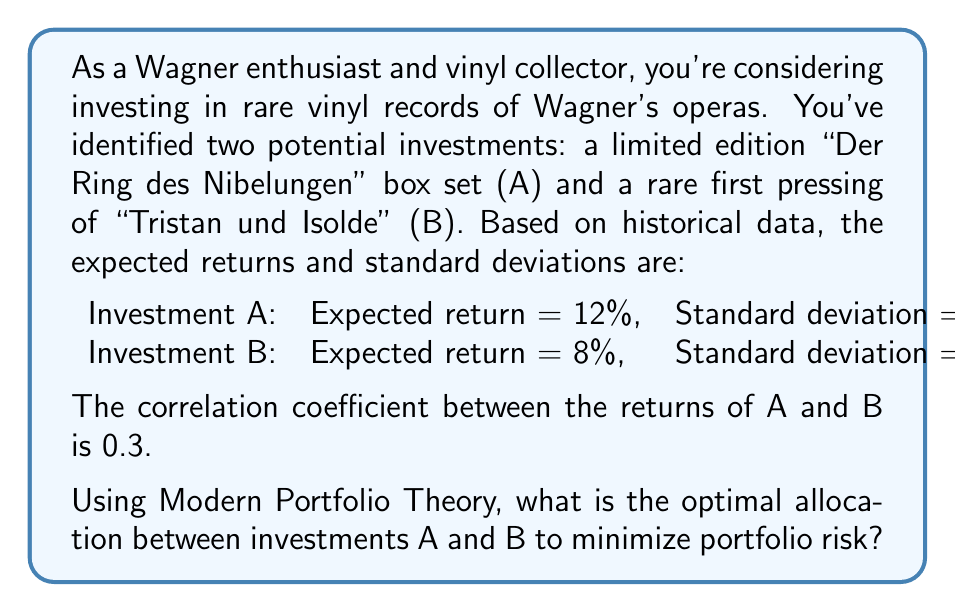Can you solve this math problem? To solve this problem, we'll use the principles of Modern Portfolio Theory to find the optimal allocation that minimizes portfolio risk. We'll follow these steps:

1. Calculate the portfolio variance formula
2. Find the derivative of the variance with respect to the weight of investment A
3. Set the derivative to zero and solve for the weight of A

Step 1: Portfolio variance formula

The portfolio variance is given by:

$$\sigma_p^2 = w_A^2\sigma_A^2 + w_B^2\sigma_B^2 + 2w_Aw_B\sigma_A\sigma_B\rho_{AB}$$

Where:
$w_A$ and $w_B$ are the weights of investments A and B
$\sigma_A$ and $\sigma_B$ are the standard deviations of A and B
$\rho_{AB}$ is the correlation coefficient between A and B

We know that $w_A + w_B = 1$, so $w_B = 1 - w_A$

Substituting the given values:

$$\sigma_p^2 = w_A^2(0.20)^2 + (1-w_A)^2(0.15)^2 + 2w_A(1-w_A)(0.20)(0.15)(0.3)$$

Step 2: Find the derivative

We differentiate the variance with respect to $w_A$:

$$\frac{d\sigma_p^2}{dw_A} = 2w_A(0.20)^2 - 2(1-w_A)(0.15)^2 + 2(1-2w_A)(0.20)(0.15)(0.3)$$

Step 3: Set derivative to zero and solve

$$0 = 2w_A(0.20)^2 - 2(1-w_A)(0.15)^2 + 2(1-2w_A)(0.20)(0.15)(0.3)$$

Simplifying:

$$0 = 0.08w_A - 0.045 + 0.045w_A + 0.018 - 0.036w_A$$

$$0 = 0.089w_A - 0.027$$

$$w_A = \frac{0.027}{0.089} \approx 0.3034$$

Therefore, the optimal weight for investment A is approximately 0.3034, and for investment B is 1 - 0.3034 = 0.6966.
Answer: The optimal allocation to minimize portfolio risk is approximately 30.34% in investment A (the "Der Ring des Nibelungen" box set) and 69.66% in investment B (the rare first pressing of "Tristan und Isolde"). 